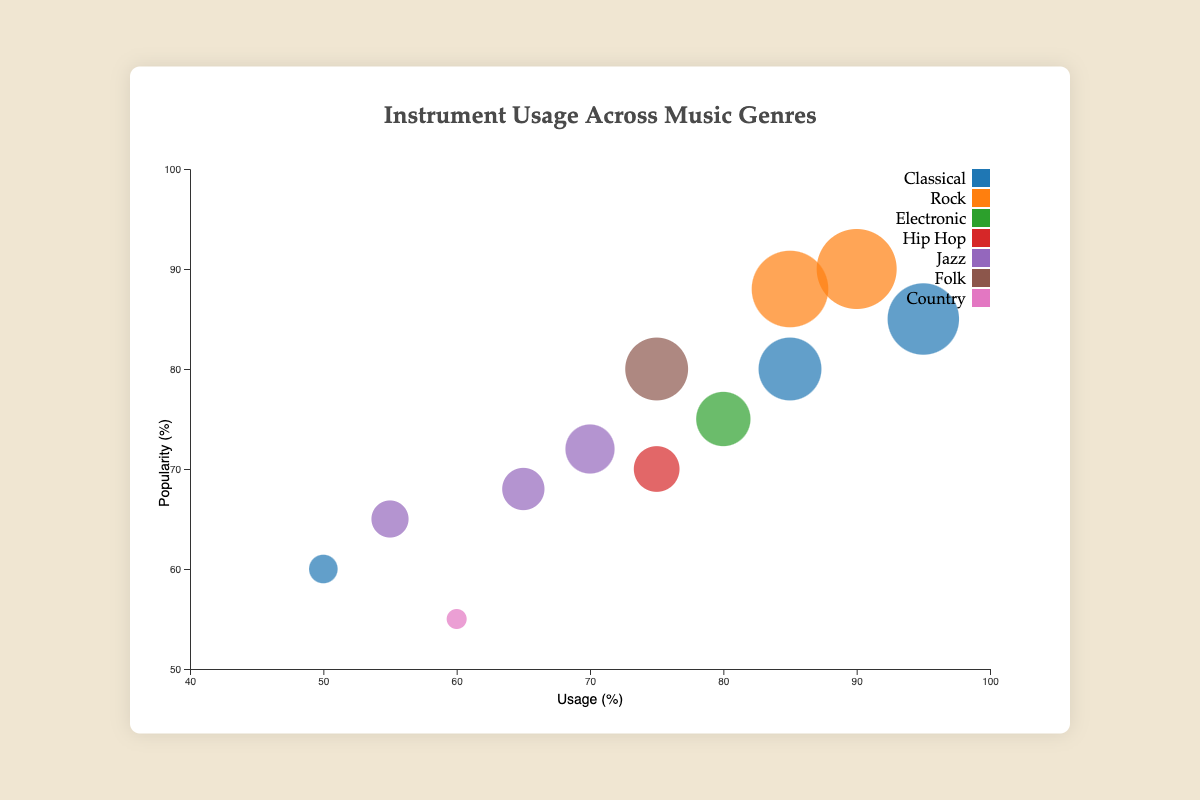How many data points are represented for the genre Classical? The Classical genre includes the instruments Piano, Violin, and Flute, resulting in 3 data points.
Answer: 3 Which instrument has the highest usage in the Rock genre? Comparing the usage percentages for Electric Guitar (90) and Drums (85) in the Rock genre, the Electric Guitar has the highest usage.
Answer: Electric Guitar What is the average popularity percentage for instruments in the Jazz genre? The Jazz genre includes Saxophone (68), Double Bass (72), and Trumpet (65). Sum up their popularities: 68 + 72 + 65 = 205. Divide by 3: 205/3 ≈ 68.33.
Answer: 68.33 Which genre has the lowest usage percentage and what is that percentage? The lowest usage percentage among all genres is for the Banjo in the Country genre at 60%.
Answer: Country, 60 How does the popularity of the Piano compare to the popularity of the Banjo? The Piano has a popularity of 85, whereas the Banjo has a popularity of 55, meaning the Piano is more popular.
Answer: Piano is more popular Which instrument has the largest bubble size on the chart and what is its popularity percentage? The Electric Guitar in the Rock genre has the largest bubble size with a popularity percentage of 90.
Answer: Electric Guitar, 90 What is the total number of unique genres represented in the chart? The genres present are Classical, Rock, Electronic, Hip Hop, Jazz, Folk, and Country, making a total of 7 unique genres.
Answer: 7 Which instrument in the Classical genre has the lowest popularity percentage, and what is that percentage? The Flute has the lowest popularity in the Classical genre with a percentage of 60.
Answer: Flute, 60 Compare the usage of Synthesizer in Electronic with Turntables in Hip Hop. Which one has higher usage? Synthesizer has a usage percentage of 80, whereas Turntables have a usage percentage of 75. Therefore, Synthesizer has higher usage.
Answer: Synthesizer 